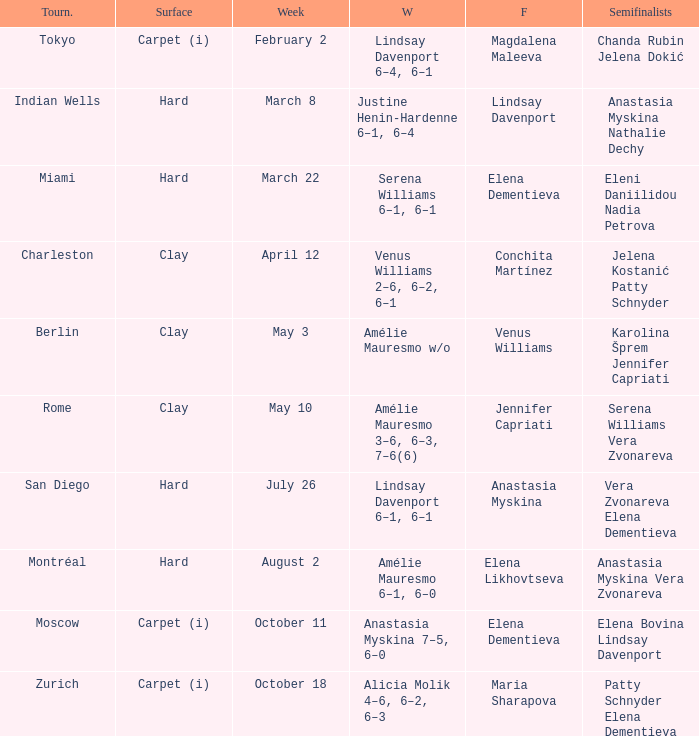Who was the winner of the Miami tournament where Elena Dementieva was a finalist? Serena Williams 6–1, 6–1. 